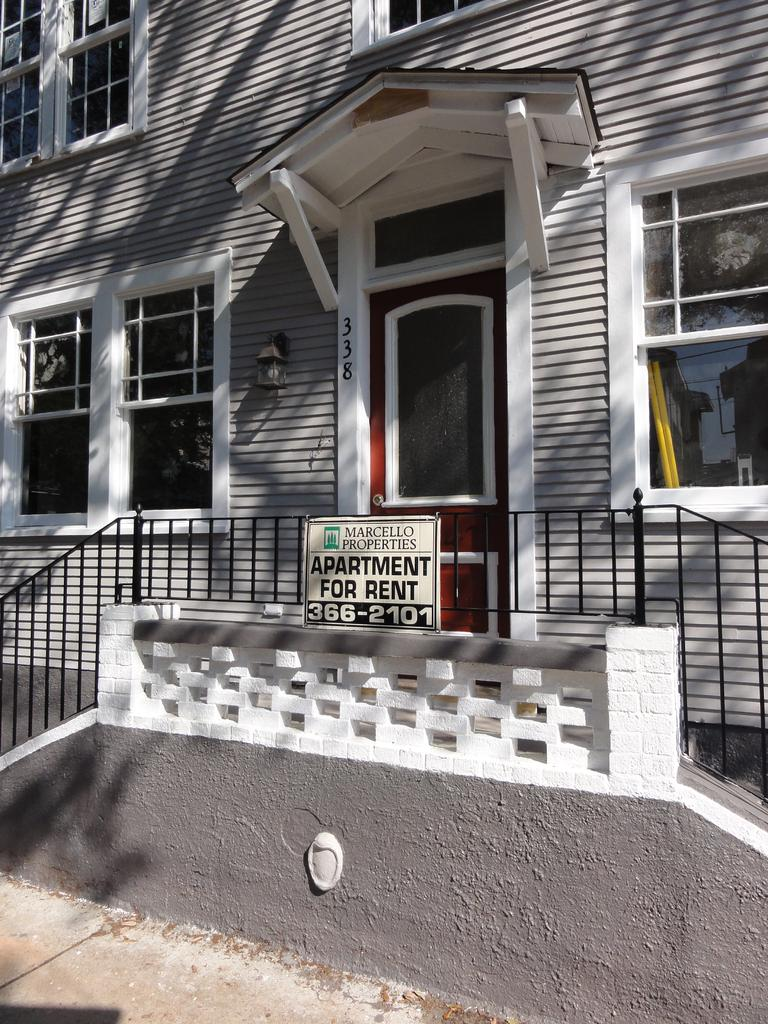What is displayed on the board in the image? There is text and numbers on a board in the image. What type of structure can be seen in the image? There is railing visible in the image, which suggests a building or platform. What type of lighting is present in the image? A lantern is present in the image. What type of objects are made of glass in the image? Glass objects are visible in the image. What type of openings are present in the building? There are windows in the image. What other objects can be seen on the building? Other objects are visible on the building. What type of bait is being used to catch fish in the image? There is no mention of fish or bait in the image; it features a board with text and numbers, railing, a lantern, glass objects, windows, and other objects on a building. Is there a baseball game taking place in the image? There is no indication of a baseball game or any sports-related activity in the image. 